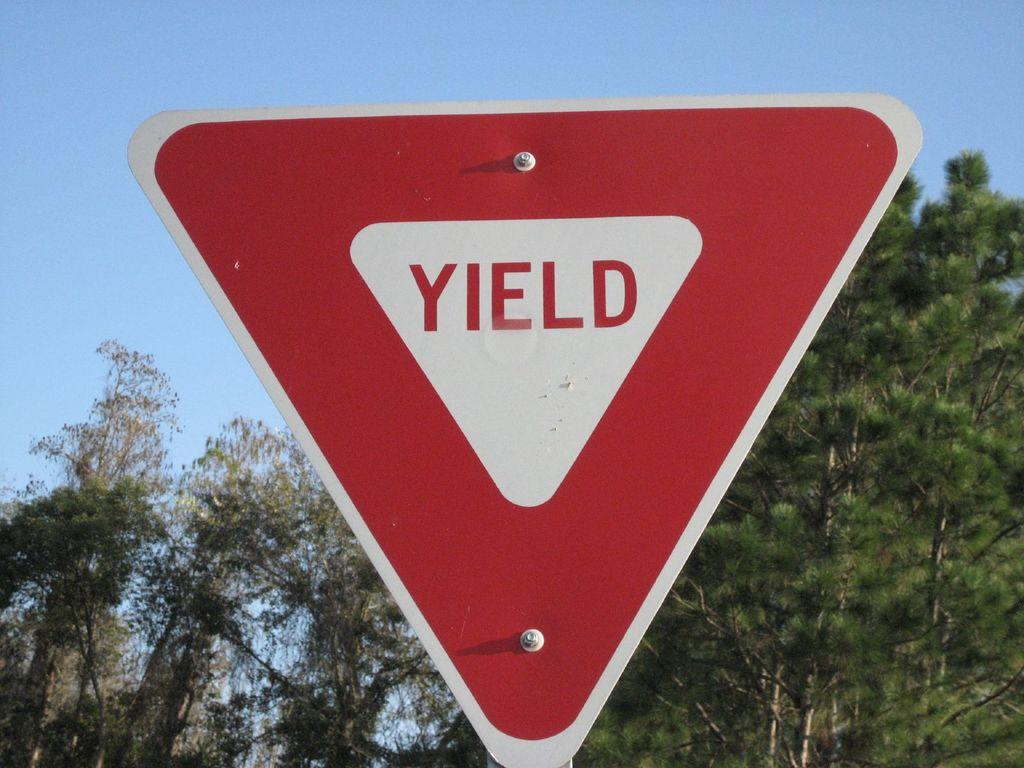<image>
Offer a succinct explanation of the picture presented. A RED AND WHITE TRIANGULAR SIGN THAT SAYS YIELD ON IT 